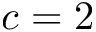<formula> <loc_0><loc_0><loc_500><loc_500>c = 2</formula> 